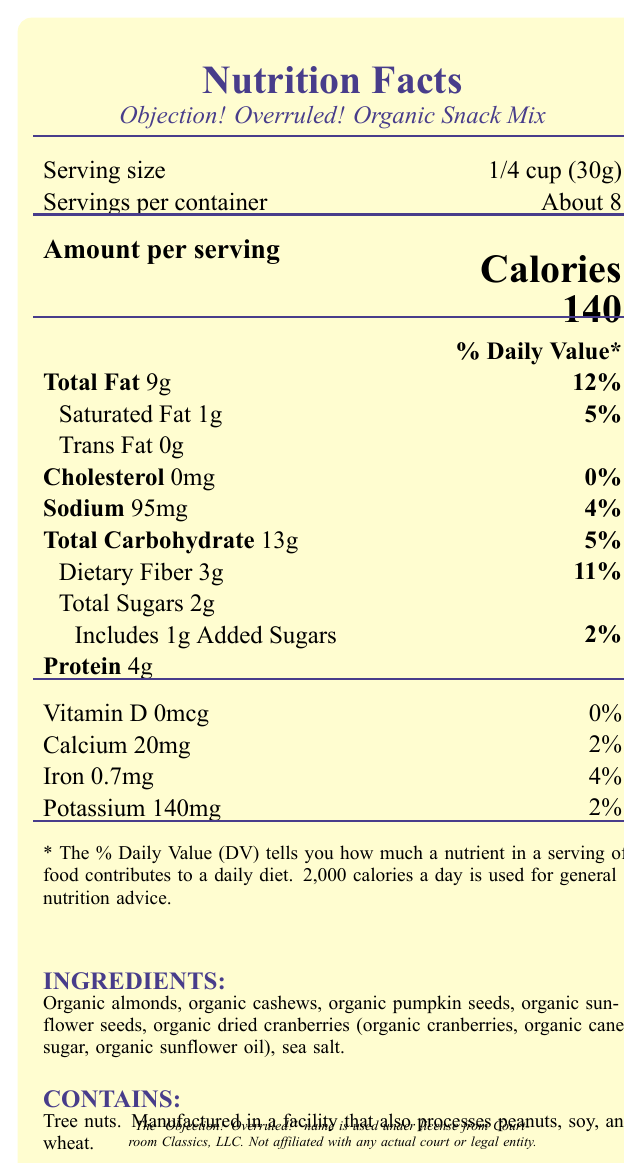what is the serving size of "Objection! Overruled! Organic Snack Mix"? The serving size is listed as "1/4 cup (30g)" under the "Serving size" section of the document.
Answer: 1/4 cup (30g) how much fiber does each serving contain? The amount of dietary fiber per serving is specified as 3g in the Nutrition Facts.
Answer: 3g what percentage of the daily value of sodium does each serving provide? The sodium section indicates 95mg of sodium, which is 4% of the daily value.
Answer: 4% how many total sugars are in one serving? The Nutrition Facts section lists 2g under "Total Sugars."
Answer: 2g how many calories are in each serving? The "Amount per serving" section clearly states there are 140 calories per serving.
Answer: 140 what is the main ingredient in the "Objection! Overruled! Organic Snack Mix"? A. Organic almonds B. Organic cashews C. Organic dried cranberries The ingredient list starts with "Organic almonds," indicating it is the main ingredient.
Answer: A. Organic almonds which vitamin is absent in this snack mix? A. Vitamin D B. Calcium C. Iron D. Potassium The document specifies that Vitamin D is present in 0mcg, which is effectively absent.
Answer: A. Vitamin D what is the daily value percentage for dietary fiber per serving? The daily value percentage for dietary fiber is given as 11% next to the dietary fiber amount.
Answer: 11% does "Objection! Overruled! Organic Snack Mix" contain trans fat? The document specifies "Trans Fat 0g," indicating there is no trans fat.
Answer: No summarize the main nutritional components and health considerations of "Objection! Overruled! Organic Snack Mix". The summary covers the detailed nutritional contents and focuses on the health-related aspects like the balance of fiber, sodium, and absence of trans fat and cholesterol.
Answer: The "Objection! Overruled! Organic Snack Mix" provides a variety of nutritional components: 140 calories per serving, 9g total fat, 1g saturated fat, 0g trans fat, 95mg sodium, 13g total carbohydrates, 3g dietary fiber, 2g total sugars (including 1g added sugars), and 4g protein. The snack is made with organic ingredients and optimized for a balance of fiber and relatively low sodium content. It also adheres to dietary considerations by containing no cholesterol and offering small amounts of minerals like calcium and iron. what are some fun facts related to this snack mix? The "Fun Facts" section provides three pieces of interesting information about the snack mix.
Answer: Each serving contains as much fiber as a small apple, the sodium is balanced for alertness, and it’s inspired by snacks favored by fictional lawyers. how much protein is in one serving of the snack mix? The Nutrition Facts specify that each serving contains 4g of protein.
Answer: 4g which nutrient contributes 0% to the daily value in the snack mix? The cholesterol section indicates 0mg, contributing 0% to the daily value.
Answer: Cholesterol who is the licensing entity for the name "Objection! Overruled!"? The legal disclaimer mentions that the name "Objection! Overruled!" is used under license from Courtroom Classics, LLC.
Answer: Courtroom Classics, LLC how many servings are in one container? The document states that there are "About 8" servings per container.
Answer: About 8 does the snack mix contain any added sugars? The document states that it includes 1g of added sugars, contributing 2% to the daily value.
Answer: Yes how does the snack mix help in maintaining alertness? One of the fun facts specifies that the sodium content is designed to maintain alertness.
Answer: The sodium content is balanced to keep you alert without causing excessive thirst. what is the approximate percentage of daily value for calcium provided by one serving? The Nutrition Facts indicate that calcium content is 20mg per serving, which is 2% of the daily value.
Answer: 2% does the document specify the total amount of fats in grams? The document specifies "Total Fat 9g" in the Nutrition Facts.
Answer: Yes is "Objection! Overruled! Organic Snack Mix" suitable for someone with nut allergies? The allergen info indicates that the snack mix contains tree nuts and is manufactured in a facility that also processes peanuts, soy, and wheat.
Answer: No 